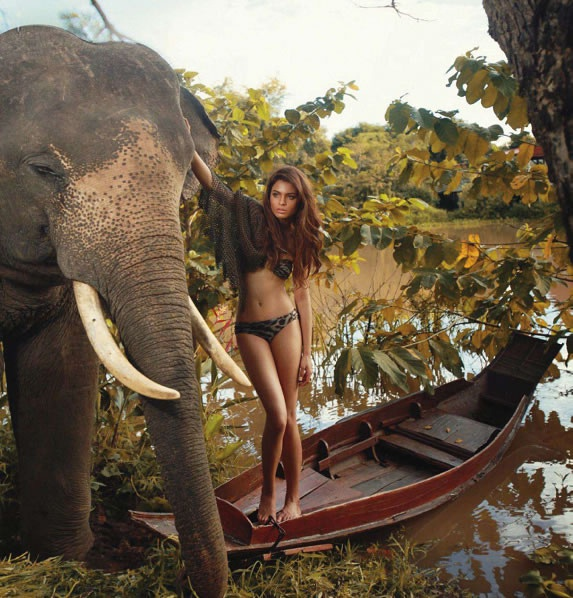Describe the objects in this image and their specific colors. I can see elephant in lightgray, black, and gray tones, boat in lightgray, black, maroon, and gray tones, and people in lightgray, black, maroon, and brown tones in this image. 